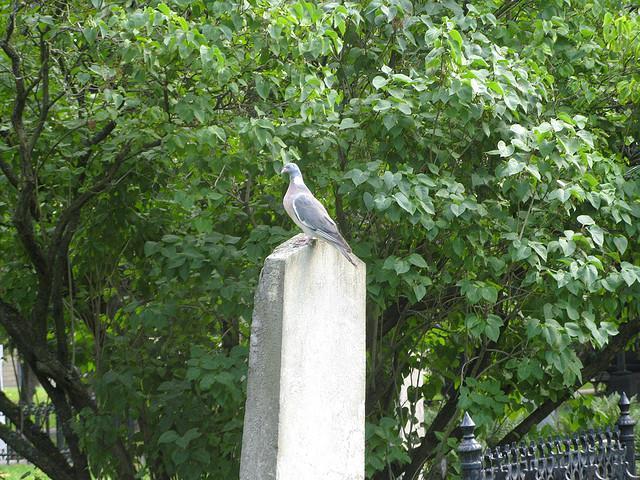How many people are sitting down?
Give a very brief answer. 0. 